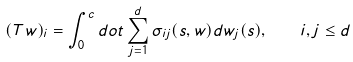Convert formula to latex. <formula><loc_0><loc_0><loc_500><loc_500>( T w ) _ { i } = \int _ { 0 } ^ { c } d o t \sum _ { j = 1 } ^ { d } \sigma _ { i j } ( s , w ) d w _ { j } ( s ) , \quad i , j \leq d</formula> 